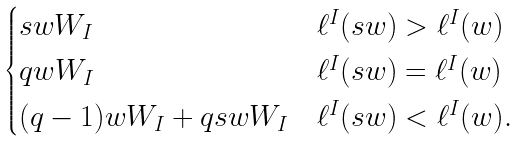Convert formula to latex. <formula><loc_0><loc_0><loc_500><loc_500>\begin{cases} s w W _ { I } & \ell ^ { I } ( s w ) > \ell ^ { I } ( w ) \\ q w W _ { I } & \ell ^ { I } ( s w ) = \ell ^ { I } ( w ) \\ ( q - 1 ) w W _ { I } + q s w W _ { I } & \ell ^ { I } ( s w ) < \ell ^ { I } ( w ) . \end{cases}</formula> 